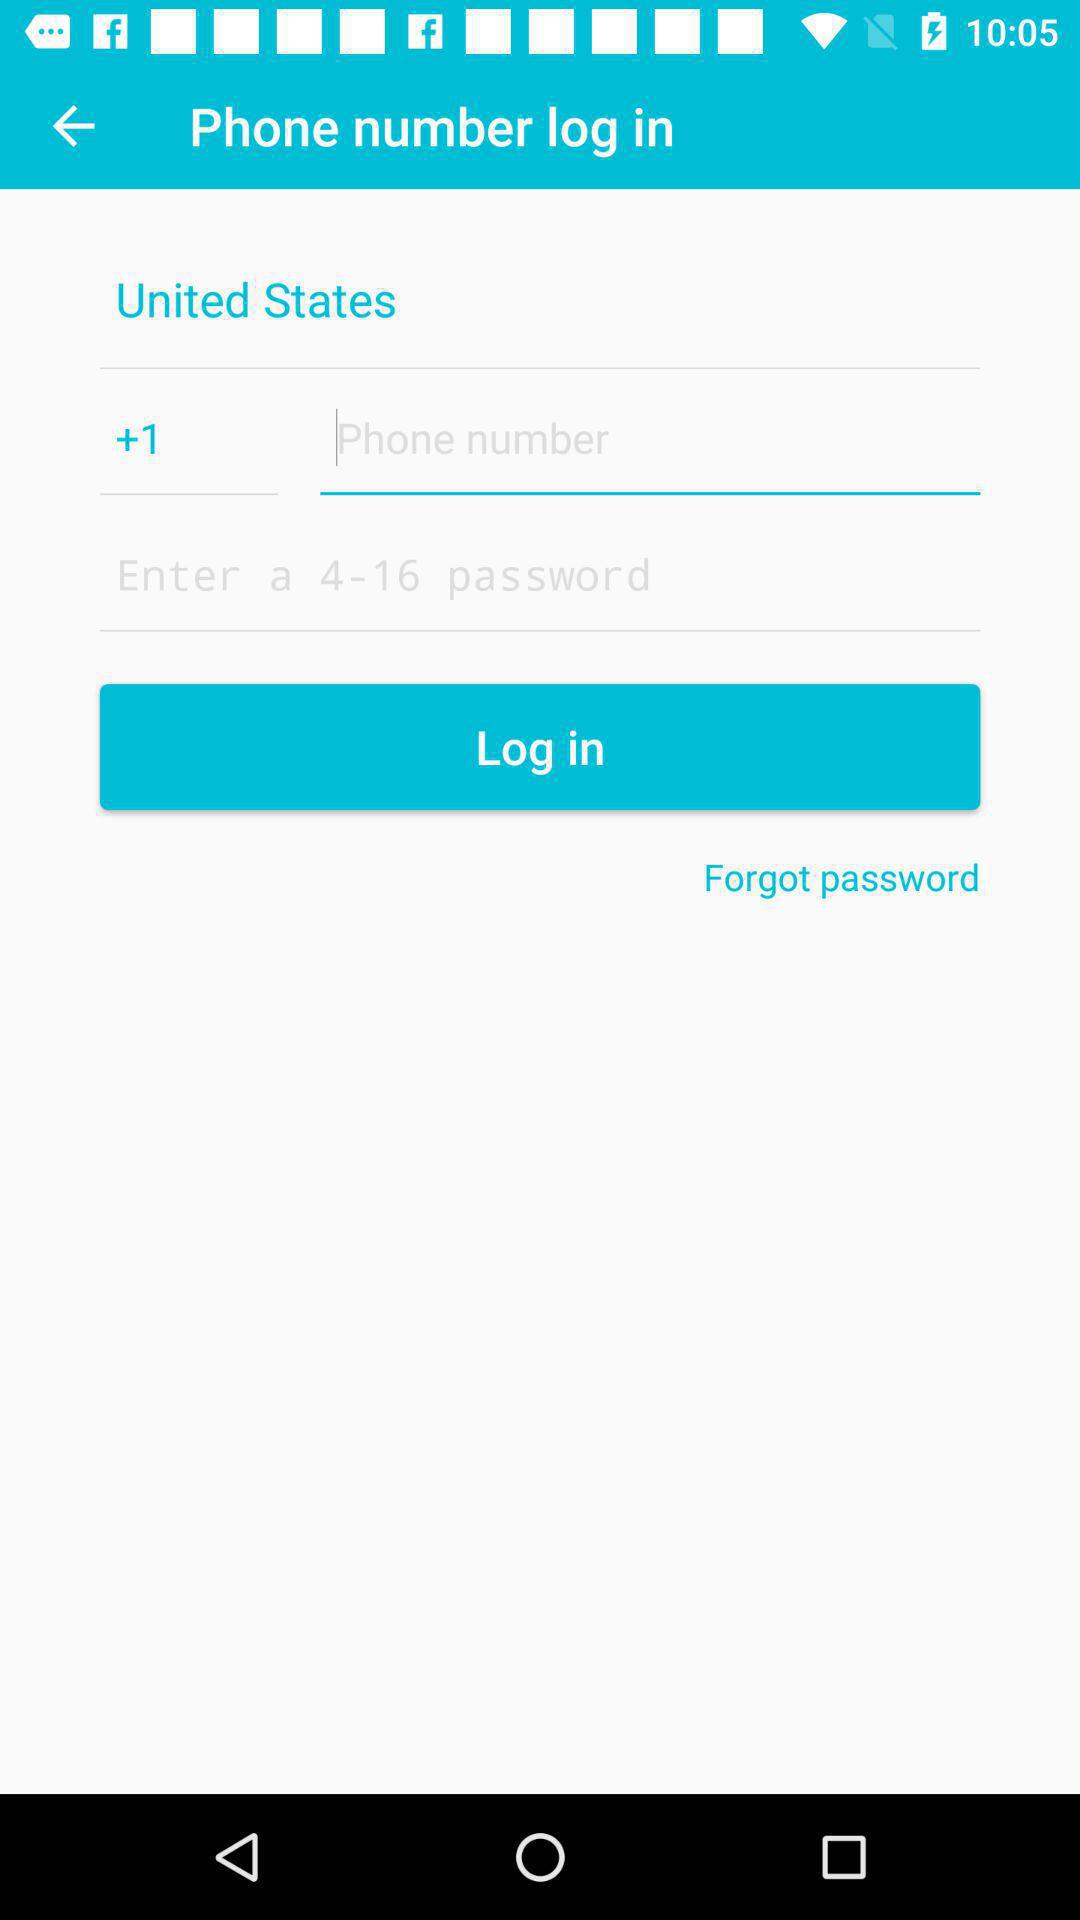What is the minimum word limit for the password? The minimum word limit is 4. 